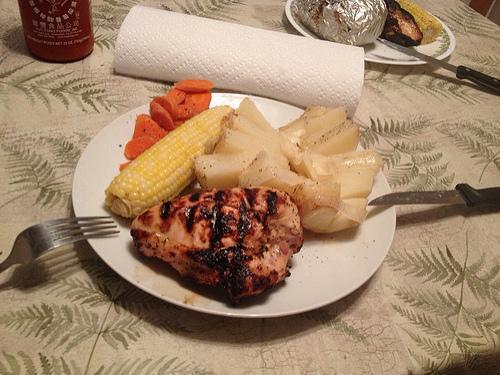How many pieces of corn on the dish?
Give a very brief answer. 1. How many pieces of meat can be seen?
Give a very brief answer. 1. How many knives in the picture?
Give a very brief answer. 2. 